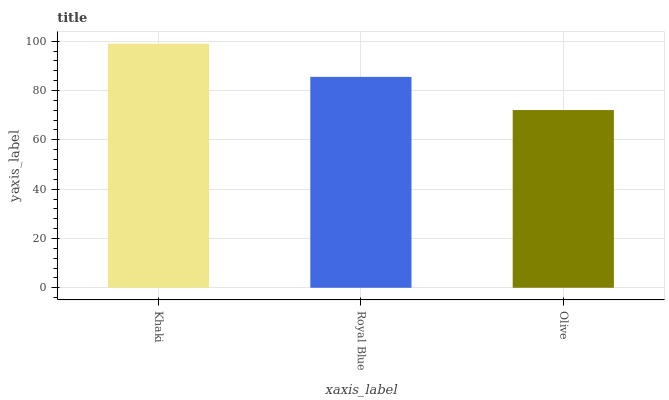Is Olive the minimum?
Answer yes or no. Yes. Is Khaki the maximum?
Answer yes or no. Yes. Is Royal Blue the minimum?
Answer yes or no. No. Is Royal Blue the maximum?
Answer yes or no. No. Is Khaki greater than Royal Blue?
Answer yes or no. Yes. Is Royal Blue less than Khaki?
Answer yes or no. Yes. Is Royal Blue greater than Khaki?
Answer yes or no. No. Is Khaki less than Royal Blue?
Answer yes or no. No. Is Royal Blue the high median?
Answer yes or no. Yes. Is Royal Blue the low median?
Answer yes or no. Yes. Is Khaki the high median?
Answer yes or no. No. Is Olive the low median?
Answer yes or no. No. 